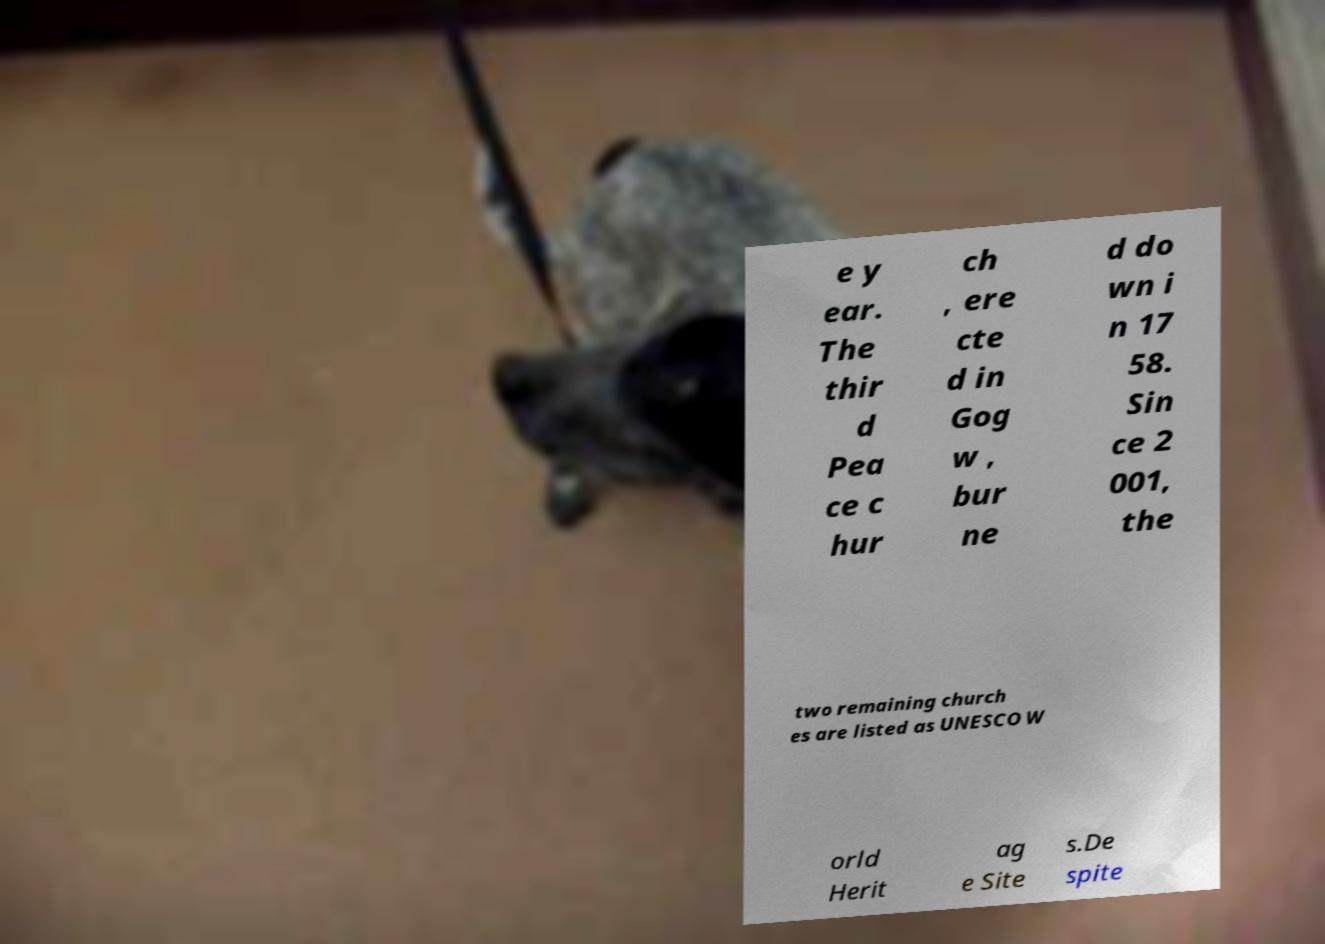I need the written content from this picture converted into text. Can you do that? e y ear. The thir d Pea ce c hur ch , ere cte d in Gog w , bur ne d do wn i n 17 58. Sin ce 2 001, the two remaining church es are listed as UNESCO W orld Herit ag e Site s.De spite 